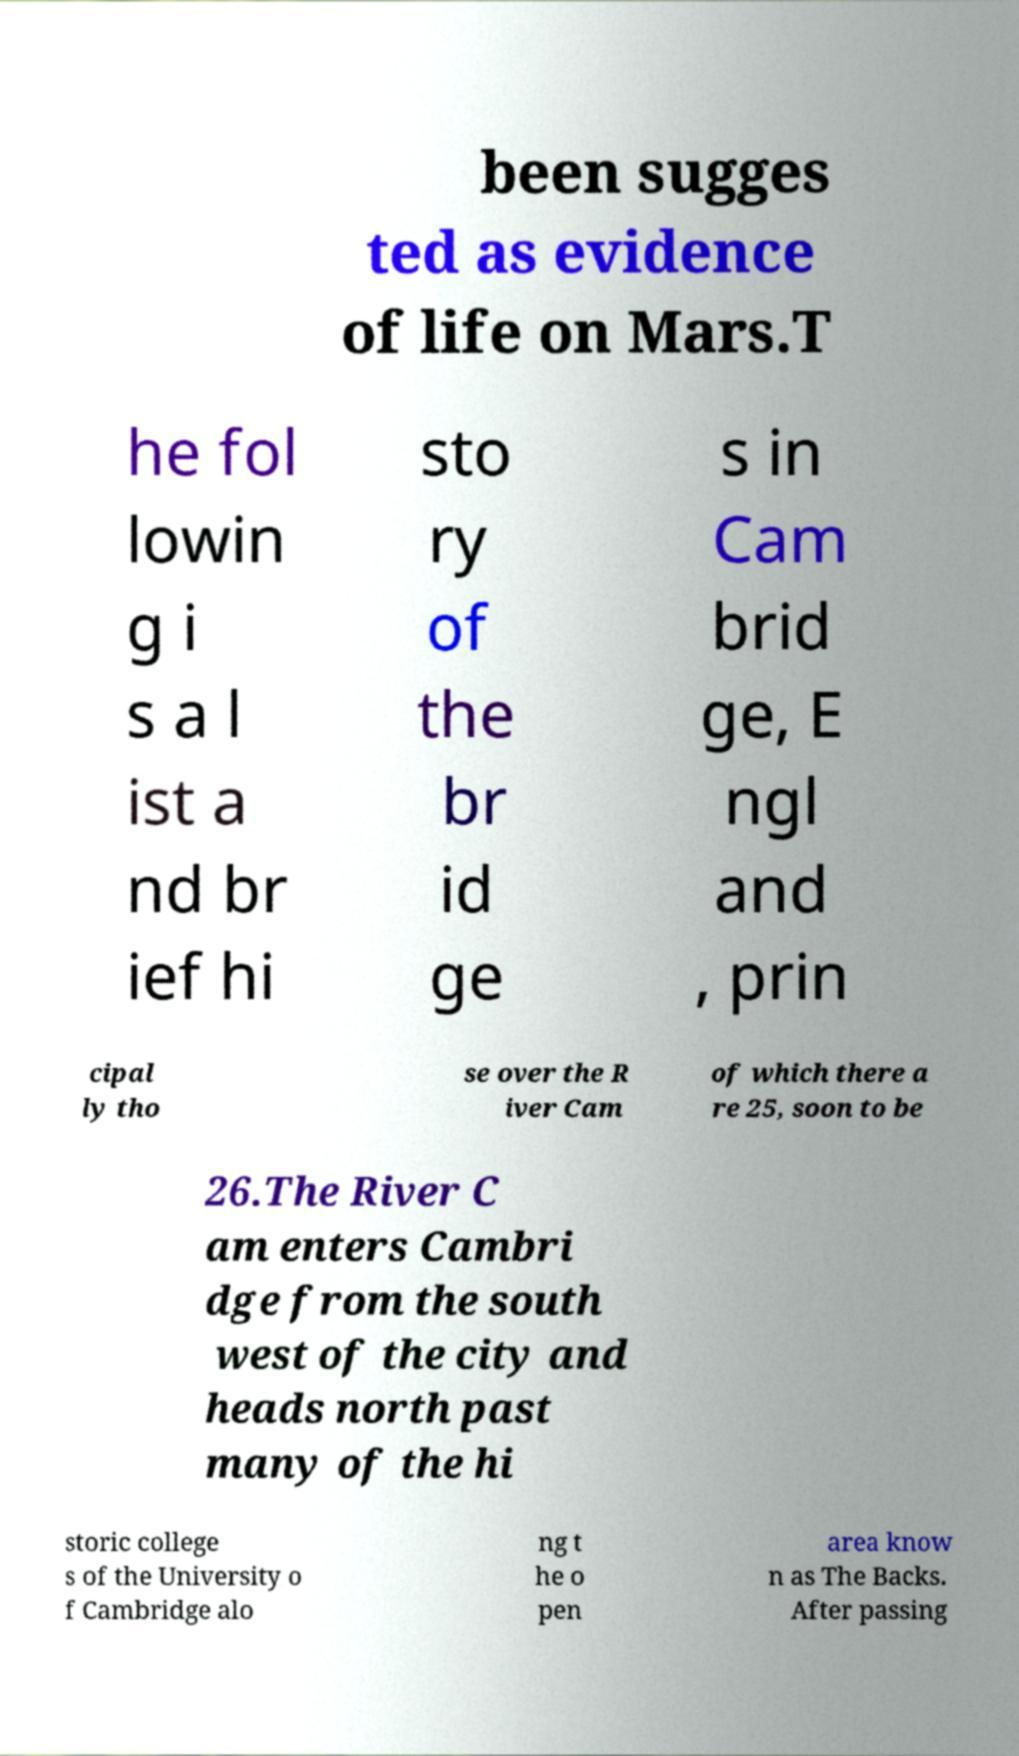For documentation purposes, I need the text within this image transcribed. Could you provide that? been sugges ted as evidence of life on Mars.T he fol lowin g i s a l ist a nd br ief hi sto ry of the br id ge s in Cam brid ge, E ngl and , prin cipal ly tho se over the R iver Cam of which there a re 25, soon to be 26.The River C am enters Cambri dge from the south west of the city and heads north past many of the hi storic college s of the University o f Cambridge alo ng t he o pen area know n as The Backs. After passing 